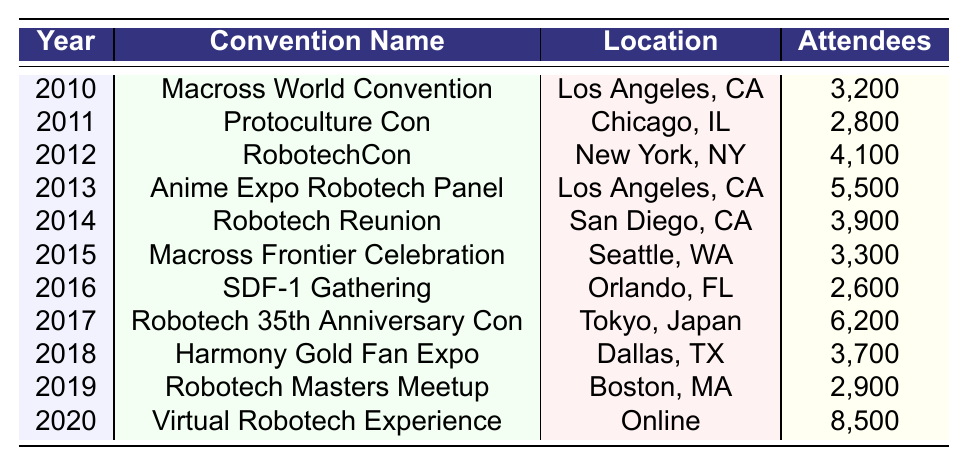What was the highest attendance recorded at a Robotech convention? The table shows the attendance numbers for each convention from 2010 to 2020. Scanning through the "Attendees" column, the highest number is 8,500 for the "Virtual Robotech Experience" in 2020.
Answer: 8,500 In which year did the "Robotech 35th Anniversary Con" take place? By looking at the convention name in the table, the "Robotech 35th Anniversary Con" is listed in the year 2017.
Answer: 2017 What is the average number of attendees for the conventions held from 2010 to 2020? To calculate the average, we sum all the "Attendees" values: (3200 + 2800 + 4100 + 5500 + 3900 + 3300 + 2600 + 6200 + 3700 + 2900 + 8500) = 40,800. Since there are 11 years, we divide 40,800 by 11 to get the average: 40,800 / 11 = 3,709.09.
Answer: 3,709.09 Was the "Anime Expo Robotech Panel" attended by more or less than 5000 people? According to the table, the "Anime Expo Robotech Panel" had 5,500 attendees, which is more than 5000.
Answer: More Which convention had the second lowest attendance, and what was that number? The table lists attendees from all conventions. The second lowest is the "SDF-1 Gathering" in 2016 with 2,600 attendees.
Answer: 2,600 How many conventions had an attendance of over 4,000 attendees? By reviewing the "Attendees" column, we find that the conventions with more than 4,000 attendees are "RobotechCon" (4,100), "Anime Expo Robotech Panel" (5,500), "Robotech 35th Anniversary Con" (6,200), and "Virtual Robotech Experience" (8,500). This totals to 4 conventions.
Answer: 4 What is the difference in attendees between the convention with the highest and lowest attendance? The highest attendance is 8,500 for the "Virtual Robotech Experience," while the lowest is 2,600 for the "SDF-1 Gathering." The difference is calculated as 8,500 - 2,600 = 5,900.
Answer: 5,900 Which year had the convention with the lowest attendance, and what was its name? Examining the table, the convention with the lowest attendance occurred in 2016, which was the "SDF-1 Gathering" with 2,600 attendees.
Answer: 2016, SDF-1 Gathering Did the attendance generally increase or decrease from 2010 to 2020? Looking through the data year-by-year, the attendance numbers show fluctuations with an initial increase till 2013, a slight decline, followed by a significant rise in 2020 for the online event. Overall, there wasn't a consistent upward or downward trend.
Answer: No consistent trend 